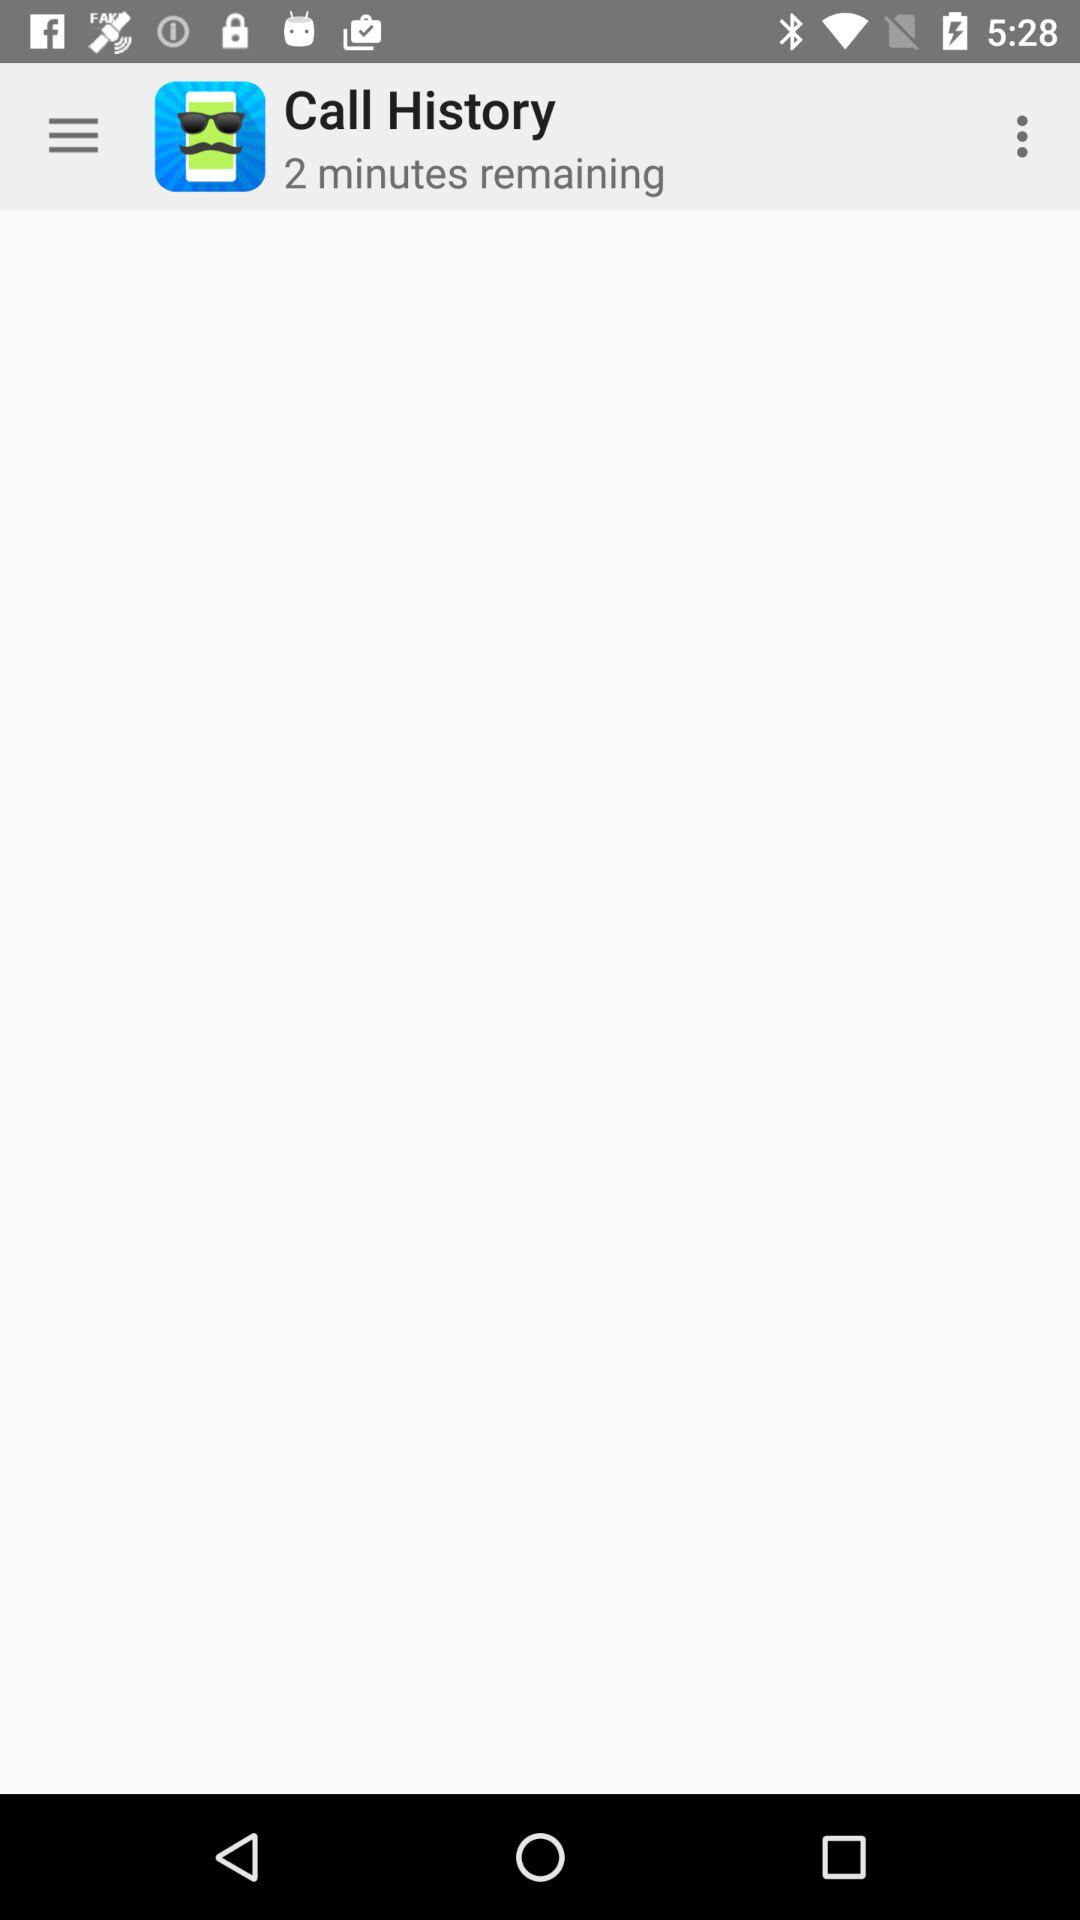How many more minutes of call time do I have remaining?
Answer the question using a single word or phrase. 2 